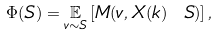<formula> <loc_0><loc_0><loc_500><loc_500>\Phi ( S ) = \underset { v \sim S } { \mathbb { E } } \left [ M ( v , X ( k ) \ S ) \right ] ,</formula> 